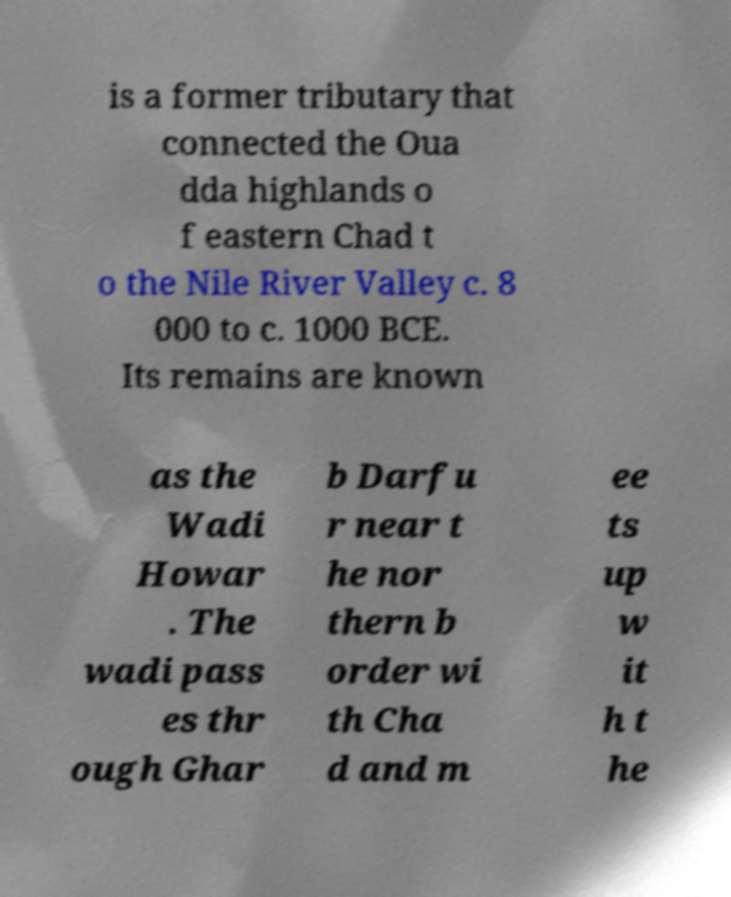Please identify and transcribe the text found in this image. is a former tributary that connected the Oua dda highlands o f eastern Chad t o the Nile River Valley c. 8 000 to c. 1000 BCE. Its remains are known as the Wadi Howar . The wadi pass es thr ough Ghar b Darfu r near t he nor thern b order wi th Cha d and m ee ts up w it h t he 